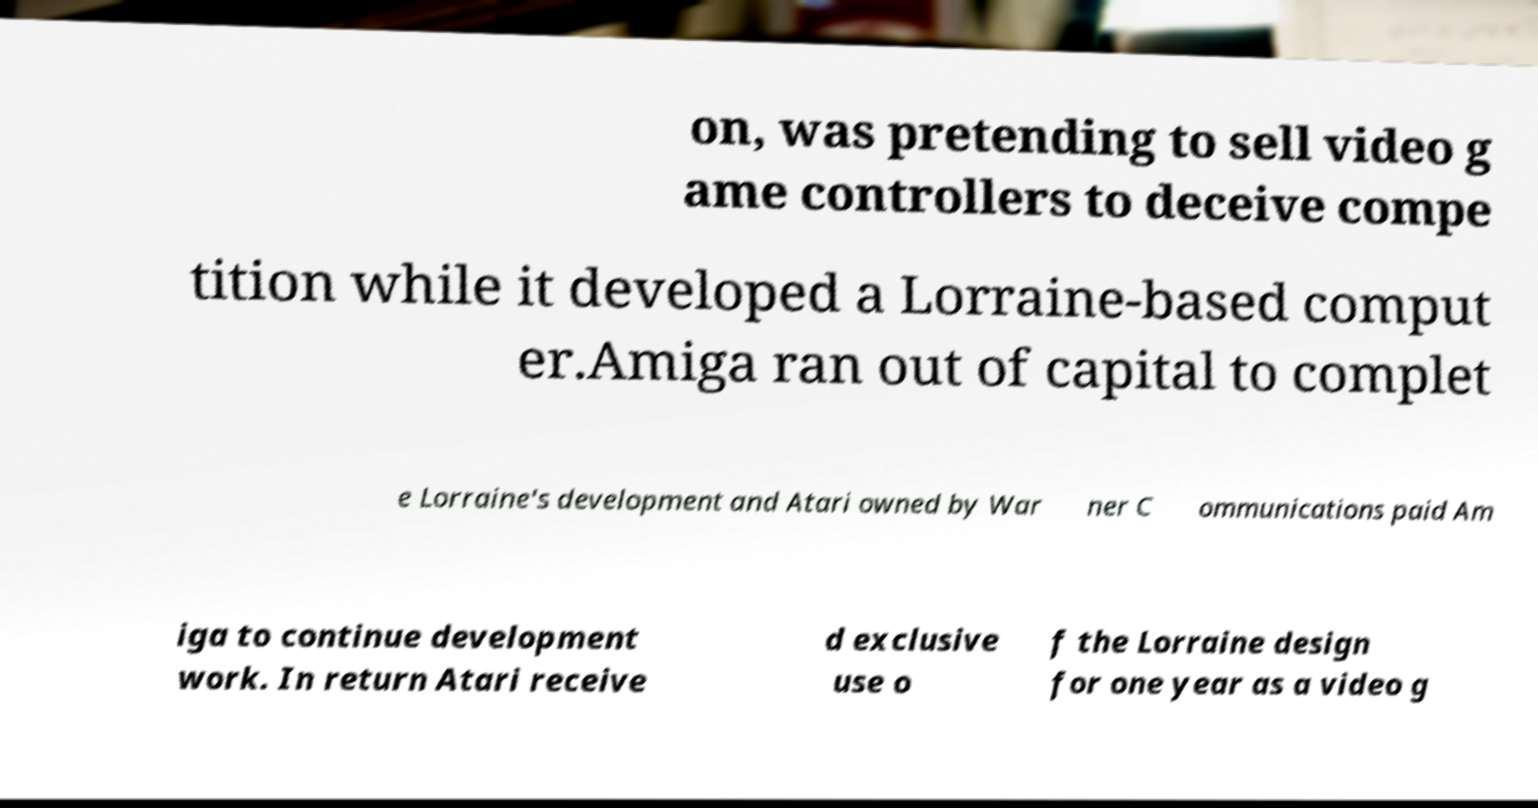I need the written content from this picture converted into text. Can you do that? on, was pretending to sell video g ame controllers to deceive compe tition while it developed a Lorraine-based comput er.Amiga ran out of capital to complet e Lorraine's development and Atari owned by War ner C ommunications paid Am iga to continue development work. In return Atari receive d exclusive use o f the Lorraine design for one year as a video g 